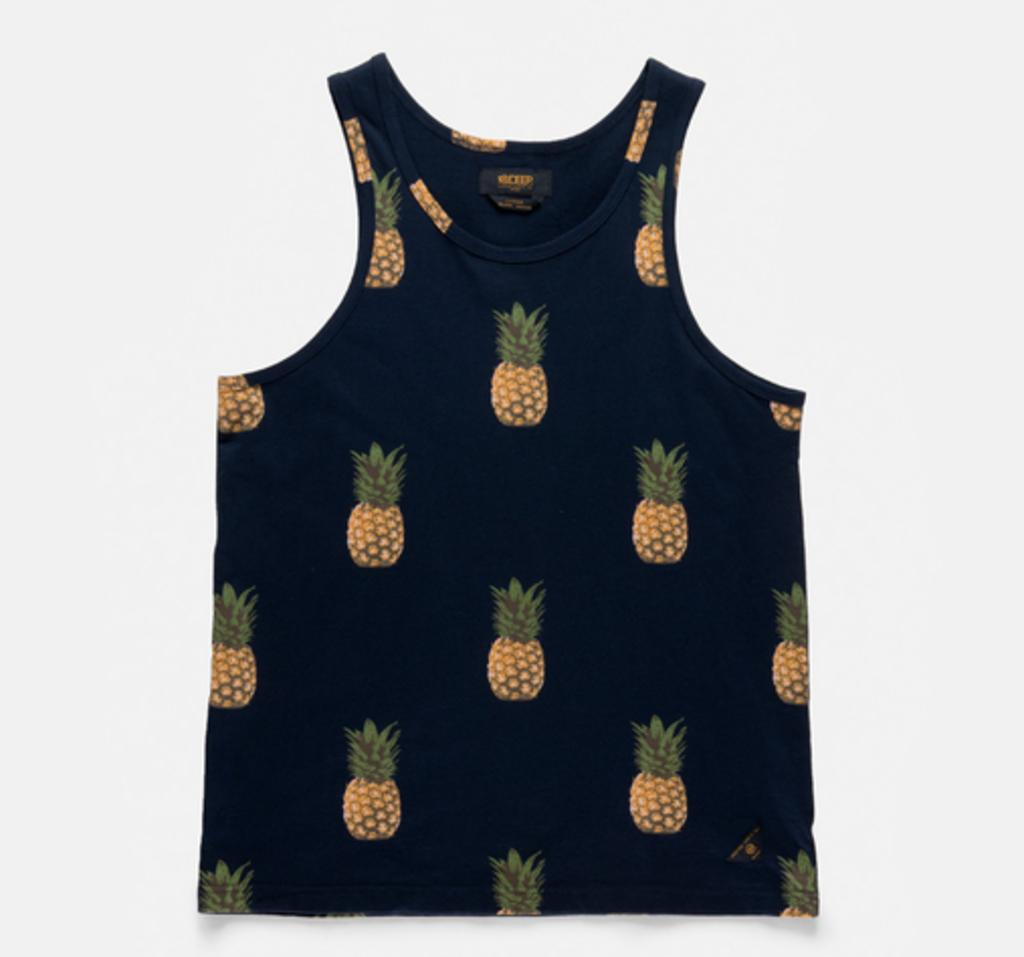What type of clothing is featured in the image? There is a tank top in the image. What design can be seen on the tank top? The tank top has pineapple prints. What type of joke is being told by the pineapple on the tank top? There is no joke being told by the pineapple on the tank top, as it is a printed design on clothing and not an actual talking pineapple. 